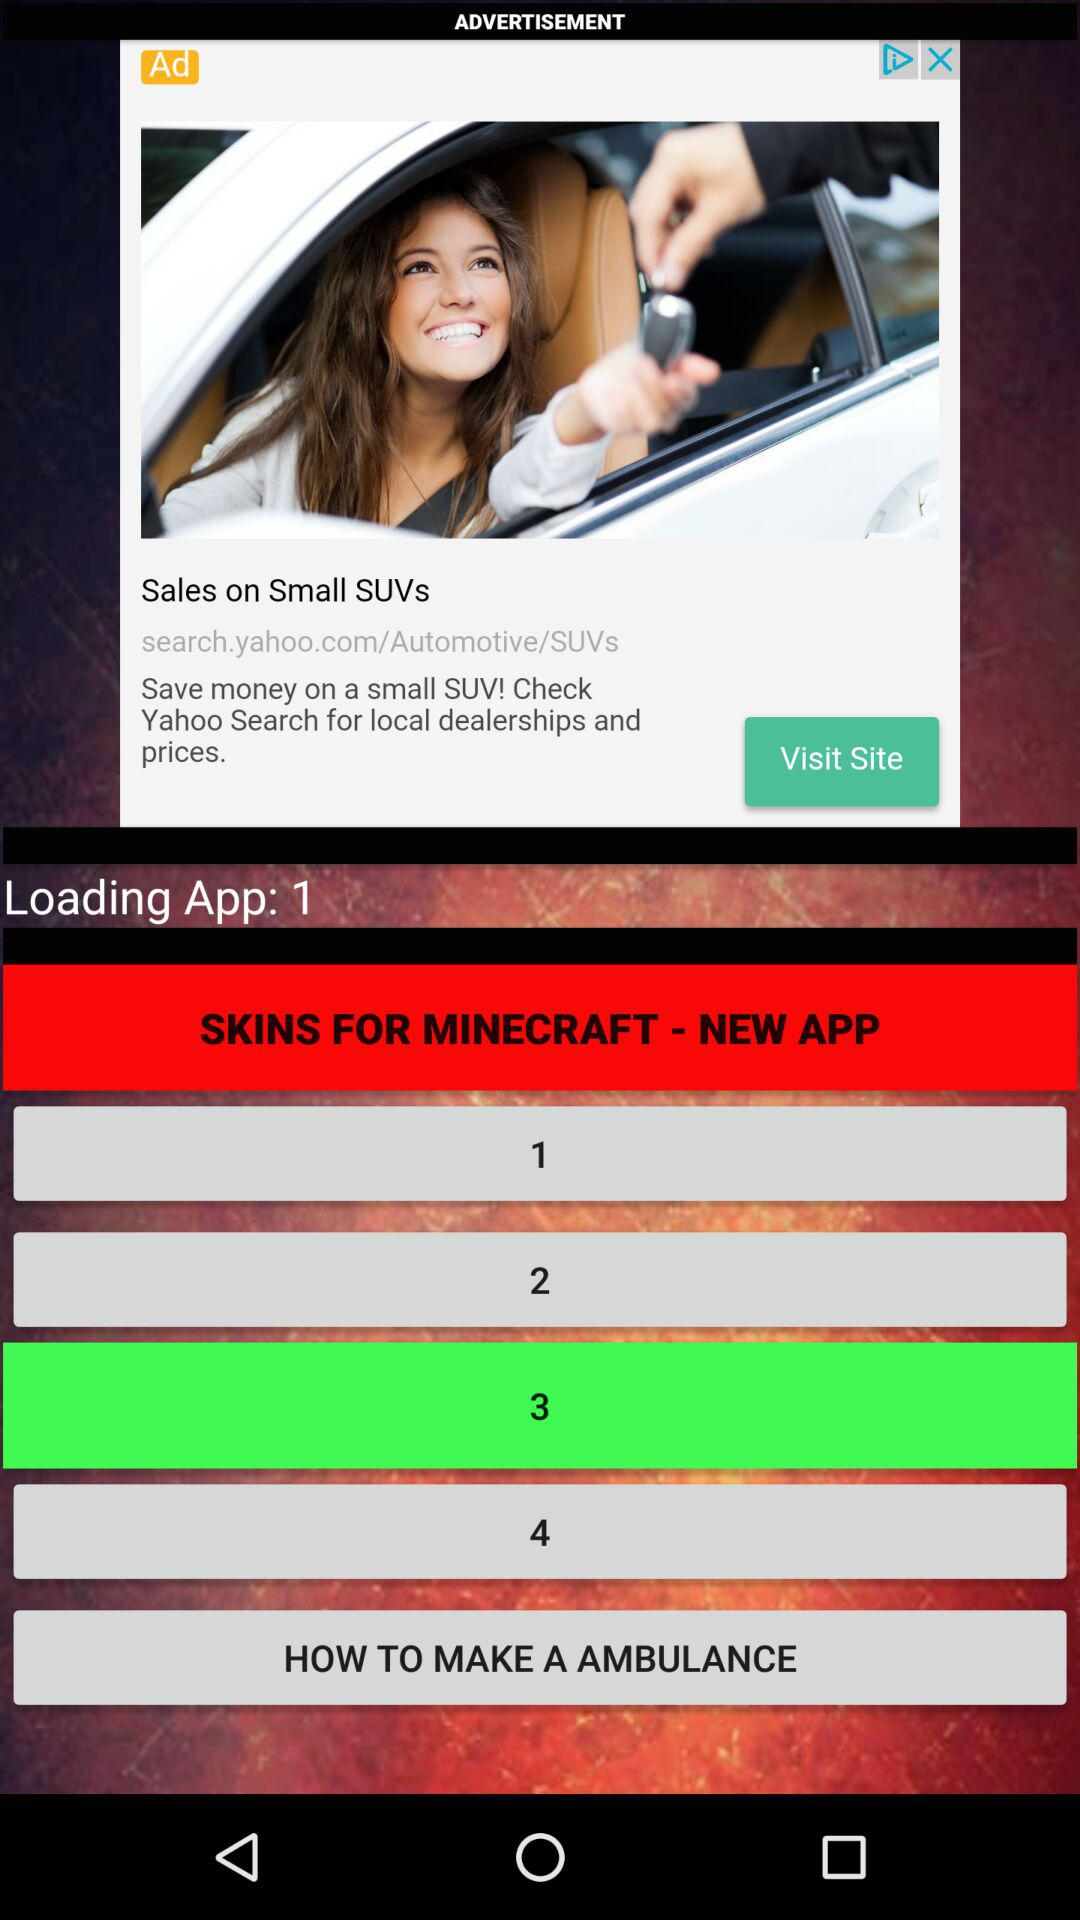What is the count of the loading app? The count is 1. 